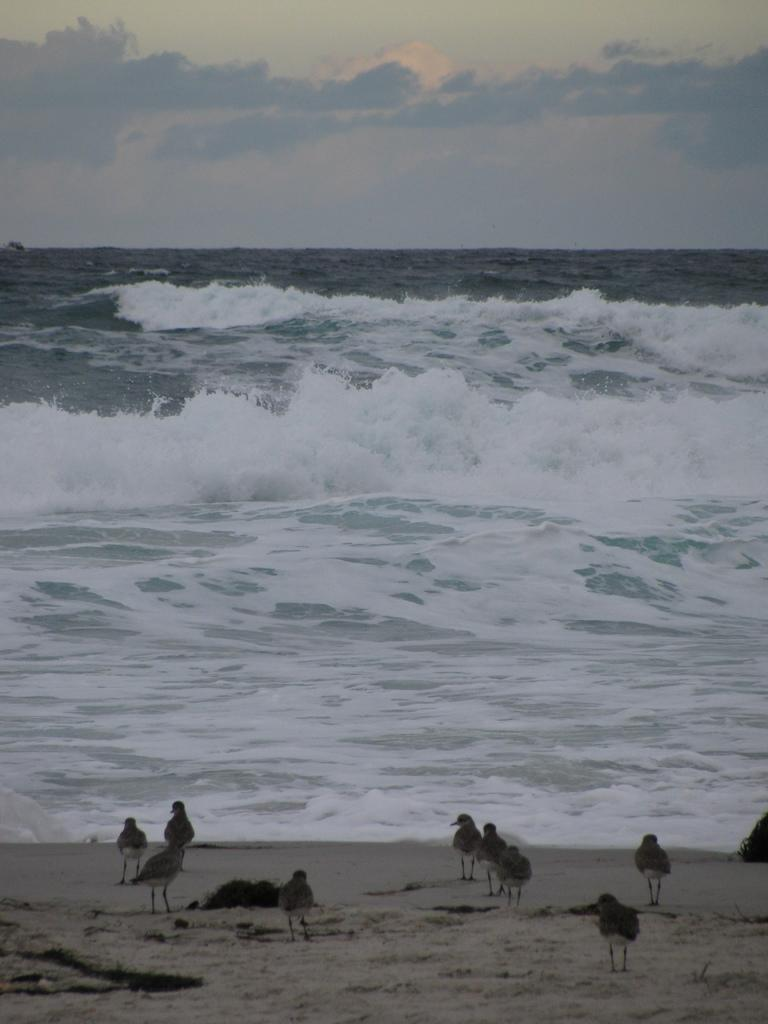What is located in the foreground of the picture? There are birds and sand in the foreground of the picture. What can be seen in the center of the picture? There is a water body in the center of the picture. What is the condition of the sky in the picture? The sky is cloudy in the picture. What type of zephyr can be seen in the image? There is no zephyr present in the image. What request is being made in the image? There is no request being made in the image. 